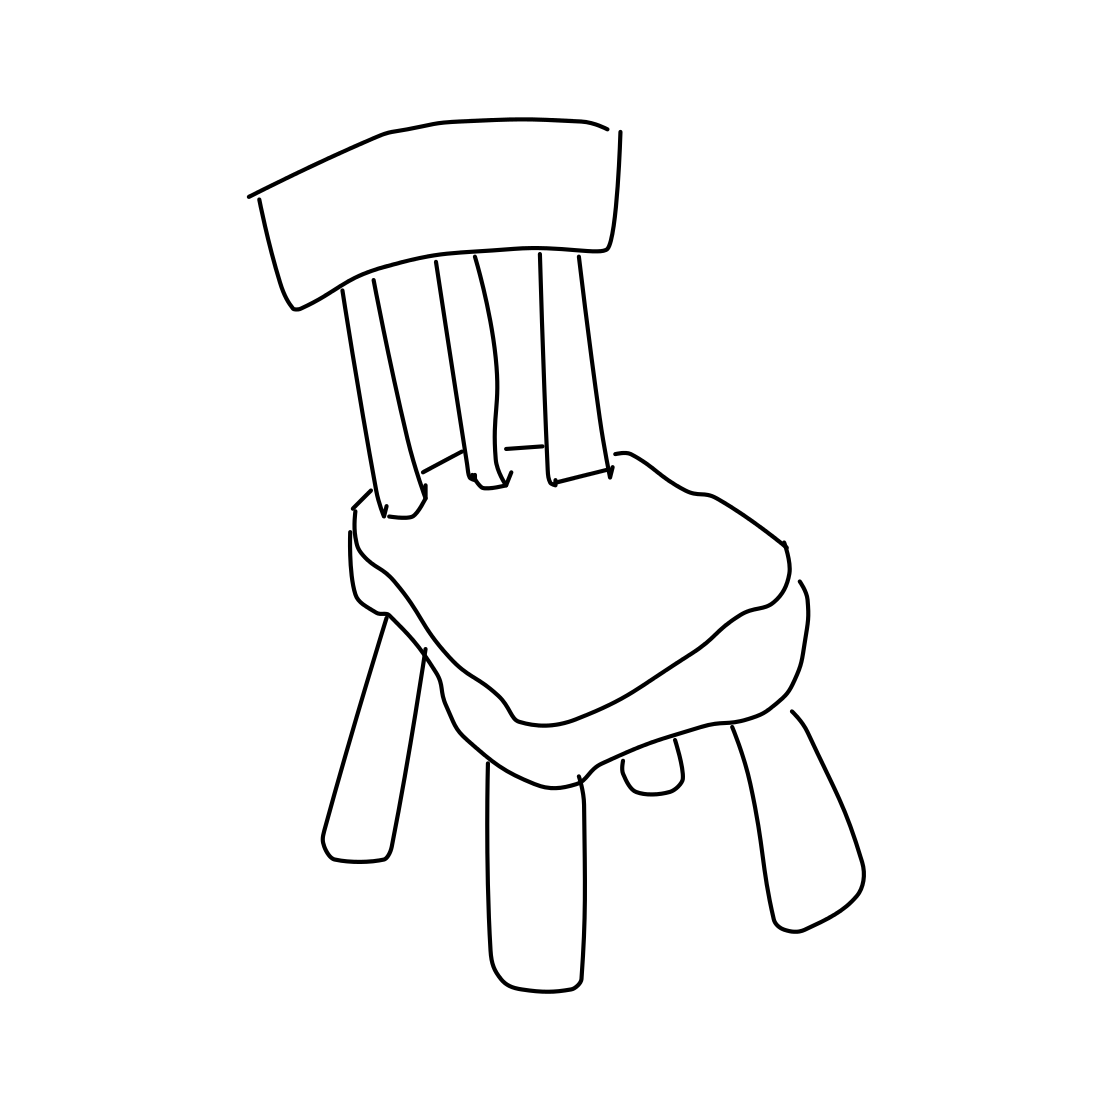Is there a sketchy spider in the picture? No 